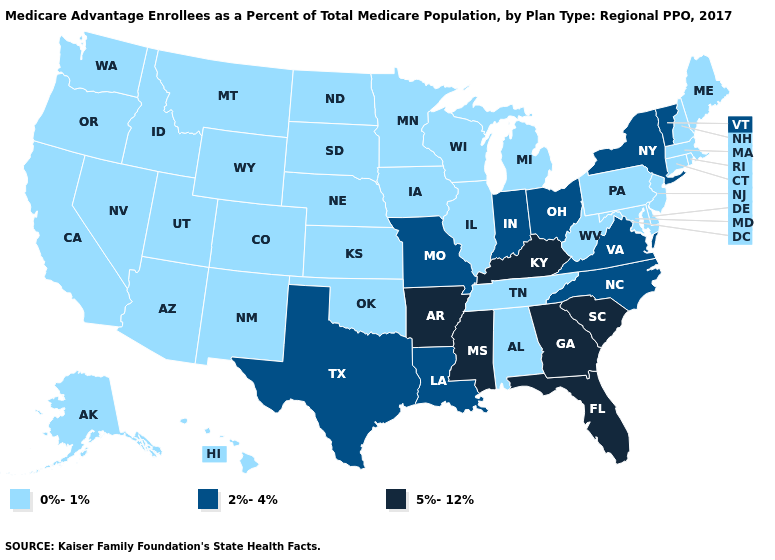Does New York have the same value as Ohio?
Answer briefly. Yes. Name the states that have a value in the range 0%-1%?
Short answer required. Alaska, Alabama, Arizona, California, Colorado, Connecticut, Delaware, Hawaii, Iowa, Idaho, Illinois, Kansas, Massachusetts, Maryland, Maine, Michigan, Minnesota, Montana, North Dakota, Nebraska, New Hampshire, New Jersey, New Mexico, Nevada, Oklahoma, Oregon, Pennsylvania, Rhode Island, South Dakota, Tennessee, Utah, Washington, Wisconsin, West Virginia, Wyoming. What is the value of Missouri?
Quick response, please. 2%-4%. What is the lowest value in the USA?
Give a very brief answer. 0%-1%. What is the value of Missouri?
Be succinct. 2%-4%. Which states have the highest value in the USA?
Concise answer only. Arkansas, Florida, Georgia, Kentucky, Mississippi, South Carolina. What is the lowest value in states that border Louisiana?
Be succinct. 2%-4%. What is the value of New York?
Short answer required. 2%-4%. What is the value of New Hampshire?
Write a very short answer. 0%-1%. Does Washington have a lower value than Virginia?
Be succinct. Yes. What is the value of North Carolina?
Answer briefly. 2%-4%. How many symbols are there in the legend?
Give a very brief answer. 3. What is the value of Colorado?
Short answer required. 0%-1%. Does the map have missing data?
Answer briefly. No. What is the highest value in states that border West Virginia?
Give a very brief answer. 5%-12%. 